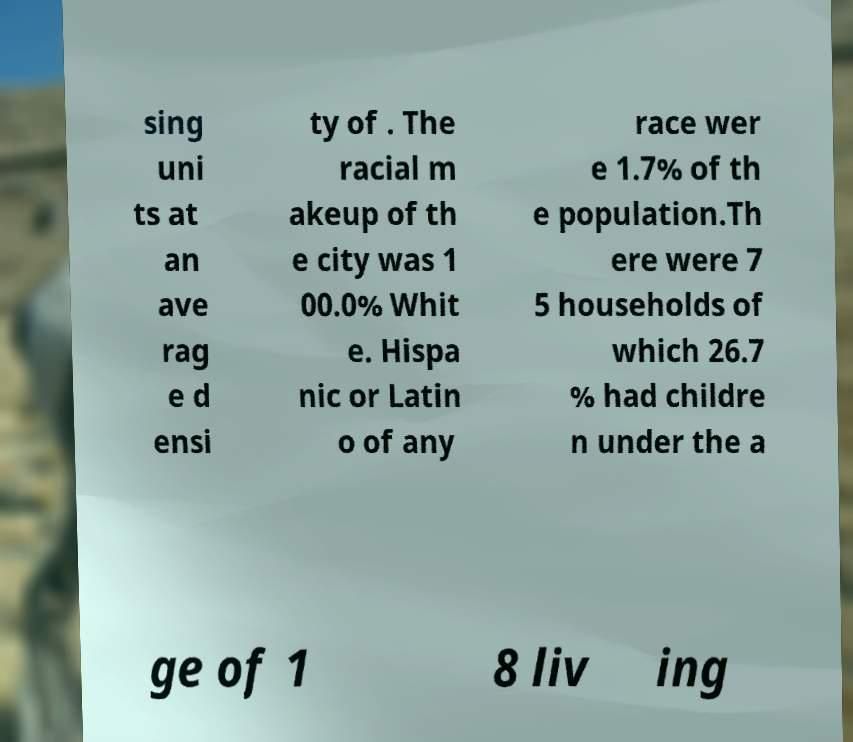For documentation purposes, I need the text within this image transcribed. Could you provide that? sing uni ts at an ave rag e d ensi ty of . The racial m akeup of th e city was 1 00.0% Whit e. Hispa nic or Latin o of any race wer e 1.7% of th e population.Th ere were 7 5 households of which 26.7 % had childre n under the a ge of 1 8 liv ing 